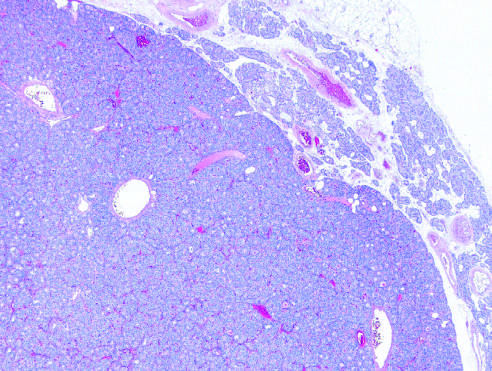s a solitary hypercellular adenoma delineated from the residual normocellular gland on the upper right in this low-power view?
Answer the question using a single word or phrase. Yes 